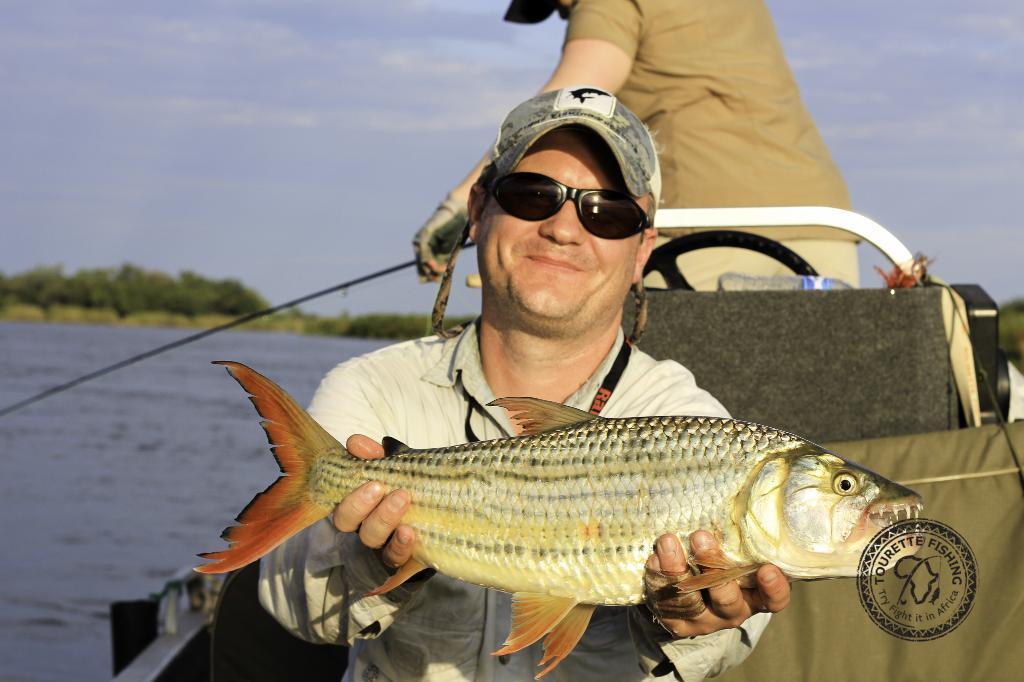Can you describe this image briefly? In this image we can see men standing in the boat and one of them is holding a fish in both the hands. In the background there are water, trees and sky with clouds. 